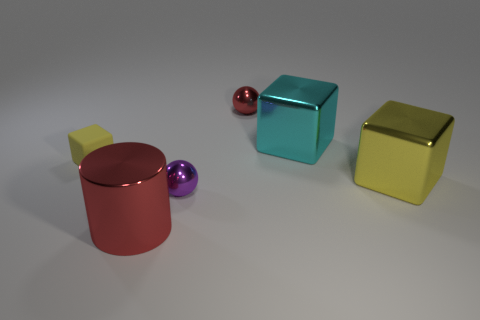Subtract all tiny yellow matte blocks. How many blocks are left? 2 Subtract all green cylinders. How many yellow blocks are left? 2 Subtract all cyan cubes. How many cubes are left? 2 Add 2 cyan matte spheres. How many objects exist? 8 Subtract all purple blocks. Subtract all brown cylinders. How many blocks are left? 3 Subtract all balls. How many objects are left? 4 Subtract 0 green blocks. How many objects are left? 6 Subtract all small cubes. Subtract all cylinders. How many objects are left? 4 Add 1 rubber things. How many rubber things are left? 2 Add 4 small yellow things. How many small yellow things exist? 5 